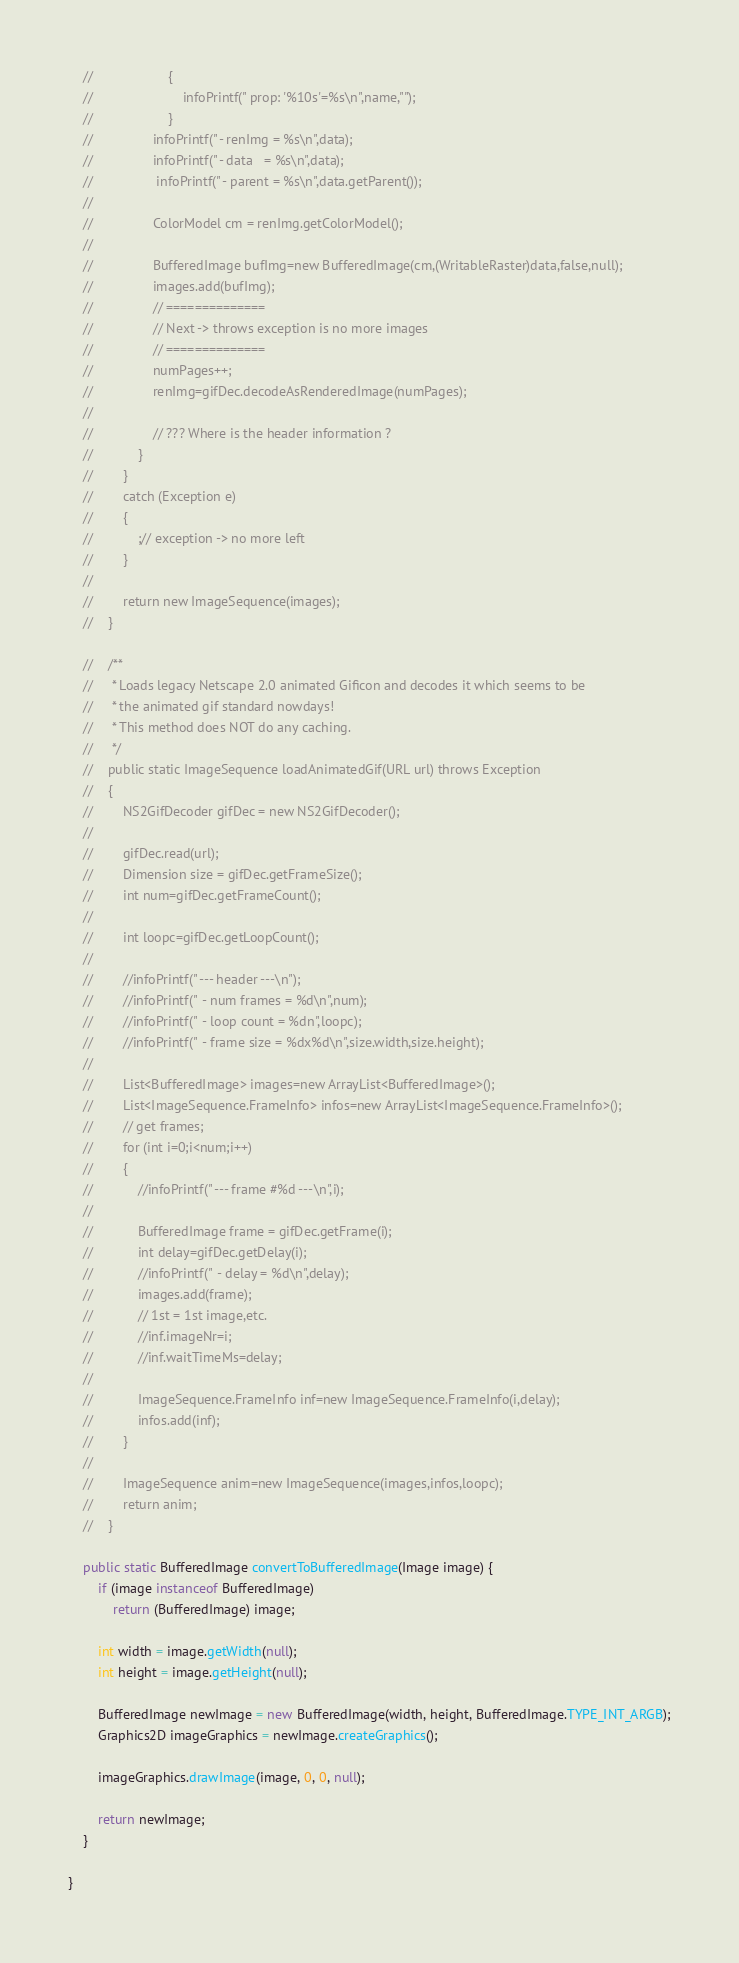<code> <loc_0><loc_0><loc_500><loc_500><_Java_>    //                    {
    //                        infoPrintf(" prop: '%10s'=%s\n",name,""); 
    //                    }
    //                infoPrintf(" - renImg = %s\n",data); 
    //                infoPrintf(" - data   = %s\n",data); 
    //                 infoPrintf(" - parent = %s\n",data.getParent()); 
    //                
    //                ColorModel cm = renImg.getColorModel(); 
    //               
    //                BufferedImage bufImg=new BufferedImage(cm,(WritableRaster)data,false,null);
    //                images.add(bufImg);
    //                // ==============
    //                // Next -> throws exception is no more images 
    //                // ==============
    //                numPages++;
    //                renImg=gifDec.decodeAsRenderedImage(numPages);
    //                
    //                // ??? Where is the header information ? 
    //            }
    //        }
    //        catch (Exception e)
    //        {
    //            ;// exception -> no more left 
    //        }
    //        
    //        return new ImageSequence(images); 
    //    }

    //    /** 
    //     * Loads legacy Netscape 2.0 animated Gificon and decodes it which seems to be 
    //     * the animated gif standard nowdays! 
    //     * This method does NOT do any caching.  
    //     */  
    //    public static ImageSequence loadAnimatedGif(URL url) throws Exception
    //    {
    //        NS2GifDecoder gifDec = new NS2GifDecoder(); 
    //        
    //        gifDec.read(url);
    //        Dimension size = gifDec.getFrameSize(); 
    //        int num=gifDec.getFrameCount(); 
    //        
    //        int loopc=gifDec.getLoopCount(); 
    //        
    //        //infoPrintf(" --- header ---\n");
    //        //infoPrintf("  - num frames = %d\n",num);  
    //        //infoPrintf("  - loop count = %dn",loopc);  
    //        //infoPrintf("  - frame size = %dx%d\n",size.width,size.height);  
    //    
    //        List<BufferedImage> images=new ArrayList<BufferedImage>(); 
    //        List<ImageSequence.FrameInfo> infos=new ArrayList<ImageSequence.FrameInfo>();
    //        // get frames; 
    //        for (int i=0;i<num;i++)
    //        {
    //            //infoPrintf(" --- frame #%d ---\n",i);
    //            
    //            BufferedImage frame = gifDec.getFrame(i);
    //            int delay=gifDec.getDelay(i); 
    //            //infoPrintf("  - delay = %d\n",delay);
    //            images.add(frame);
    //            // 1st = 1st image,etc. 
    //            //inf.imageNr=i;
    //            //inf.waitTimeMs=delay; 
    //    
    //            ImageSequence.FrameInfo inf=new ImageSequence.FrameInfo(i,delay);
    //            infos.add(inf); 
    //        }   
    //        
    //        ImageSequence anim=new ImageSequence(images,infos,loopc);
    //        return anim; 
    //    }

    public static BufferedImage convertToBufferedImage(Image image) {
        if (image instanceof BufferedImage)
            return (BufferedImage) image;

        int width = image.getWidth(null);
        int height = image.getHeight(null);

        BufferedImage newImage = new BufferedImage(width, height, BufferedImage.TYPE_INT_ARGB);
        Graphics2D imageGraphics = newImage.createGraphics();

        imageGraphics.drawImage(image, 0, 0, null);

        return newImage;
    }

}
</code> 